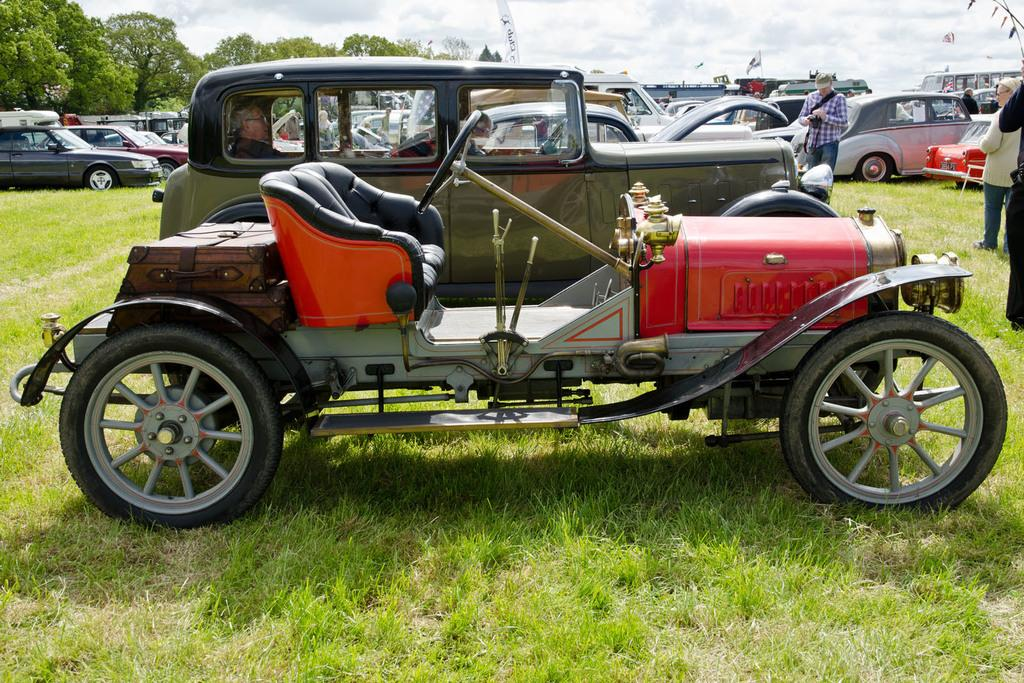How many people can be seen in the image? There are people present in the image. What else is visible in the image besides people? There are vehicles present in the image. What type of terrain is visible at the bottom of the image? The grassy land is visible at the bottom of the image. What can be seen in the background of the image? Trees are present in the background of the image. What is visible at the top of the image? The sky is visible at the top of the image. Are the sisters saying good-bye to each other in the image? There is no mention of sisters or a good-bye in the image, so we cannot answer that question. 